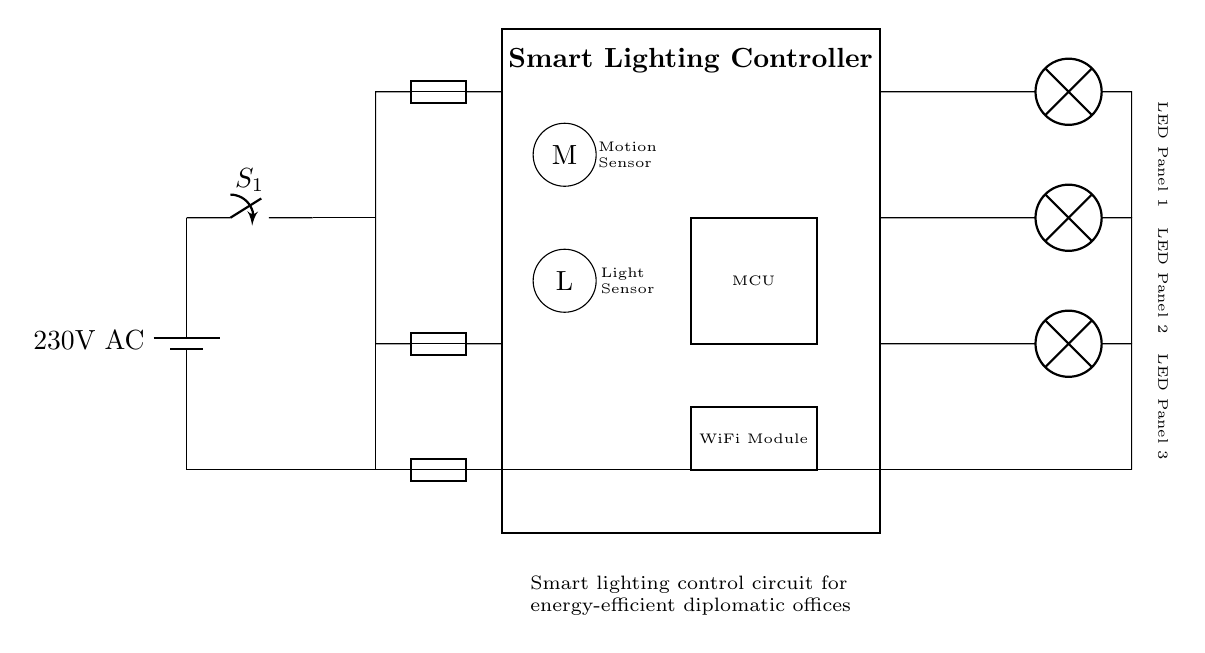What is the power source voltage of this circuit? The power source labeled in the diagram is a battery, indicating the voltage is 230 volts AC. This is specified in the labeling connected to the battery symbol in the circuit.
Answer: 230 volts AC What are the main components in the smart lighting controller? The main components include the motion sensor, light sensor, microcontroller, and WiFi module, as indicated by the labels inside and around the rectangular smart lighting controller block.
Answer: Motion sensor, light sensor, microcontroller, WiFi module How many LED panels are connected to this circuit? The diagram shows three LED panels connected to the outputs of the smart lighting controller. Each panel is specifically labeled, indicating their individual connection lines.
Answer: Three Which component controls the on/off state of the circuit? The main switch, labeled as S1, is responsible for controlling the on/off state of the circuit as it is positioned at the beginning of the circuit flow right after the power source.
Answer: Main switch What is the function of the motion sensor in this circuit? The motion sensor detects the presence of motion in the office environment, allowing the microcontroller to adjust the lighting based on occupancy. This is inferred from the overarching purpose of smart lighting control systems.
Answer: Detect motion How does the WiFi module contribute to energy efficiency? The WiFi module allows remote control and automation of the lighting system, enabling energy-saving measures such as scheduling and adjustments based on real-time data, contributing to overall energy efficiency. This is inferred from its role in smart systems.
Answer: Remote control and automation What is the purpose of the fuses in this circuit? The fuses provide overcurrent protection for each branch of the circuit, ensuring that in case of a fault, they blow before damaging other components. This is standard practice in electrical circuits to prevent overloads.
Answer: Overcurrent protection 